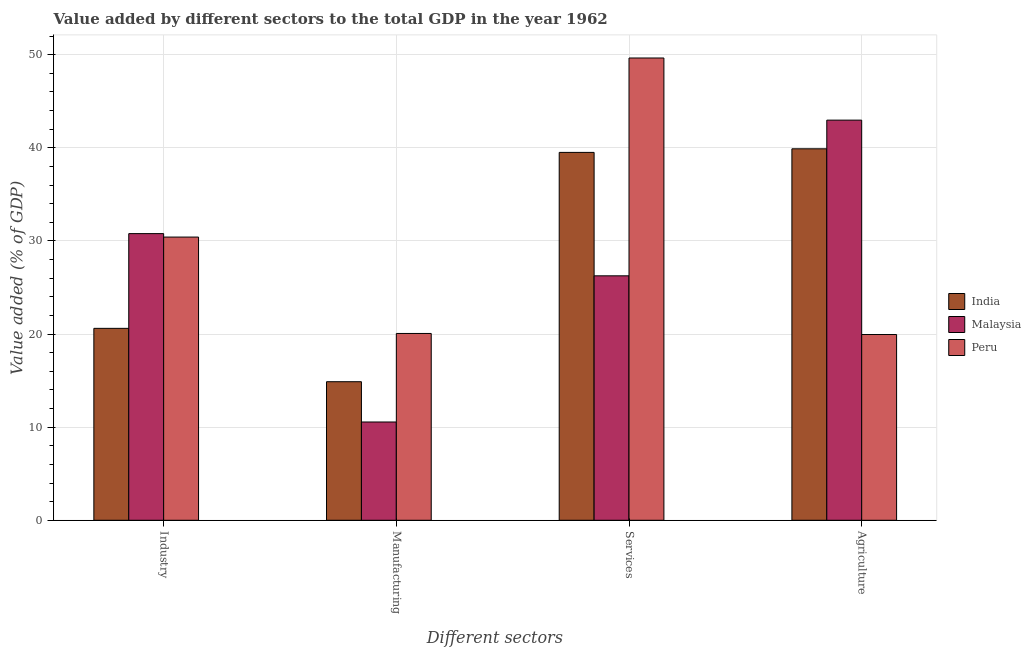How many groups of bars are there?
Your answer should be compact. 4. Are the number of bars per tick equal to the number of legend labels?
Ensure brevity in your answer.  Yes. Are the number of bars on each tick of the X-axis equal?
Provide a short and direct response. Yes. How many bars are there on the 3rd tick from the right?
Your answer should be compact. 3. What is the label of the 4th group of bars from the left?
Offer a terse response. Agriculture. What is the value added by manufacturing sector in Malaysia?
Offer a terse response. 10.55. Across all countries, what is the maximum value added by agricultural sector?
Your response must be concise. 42.97. Across all countries, what is the minimum value added by industrial sector?
Keep it short and to the point. 20.61. In which country was the value added by industrial sector maximum?
Give a very brief answer. Malaysia. What is the total value added by services sector in the graph?
Give a very brief answer. 115.39. What is the difference between the value added by industrial sector in Peru and that in India?
Provide a short and direct response. 9.8. What is the difference between the value added by agricultural sector in Malaysia and the value added by manufacturing sector in India?
Provide a succinct answer. 28.09. What is the average value added by manufacturing sector per country?
Provide a succinct answer. 15.16. What is the difference between the value added by agricultural sector and value added by industrial sector in India?
Offer a very short reply. 19.28. In how many countries, is the value added by manufacturing sector greater than 16 %?
Provide a succinct answer. 1. What is the ratio of the value added by industrial sector in Peru to that in India?
Your response must be concise. 1.48. Is the value added by services sector in Peru less than that in Malaysia?
Your answer should be very brief. No. Is the difference between the value added by services sector in India and Malaysia greater than the difference between the value added by manufacturing sector in India and Malaysia?
Provide a succinct answer. Yes. What is the difference between the highest and the second highest value added by agricultural sector?
Give a very brief answer. 3.08. What is the difference between the highest and the lowest value added by manufacturing sector?
Provide a succinct answer. 9.51. In how many countries, is the value added by services sector greater than the average value added by services sector taken over all countries?
Your answer should be very brief. 2. What does the 2nd bar from the left in Agriculture represents?
Keep it short and to the point. Malaysia. What does the 1st bar from the right in Services represents?
Your response must be concise. Peru. Is it the case that in every country, the sum of the value added by industrial sector and value added by manufacturing sector is greater than the value added by services sector?
Keep it short and to the point. No. How many bars are there?
Provide a short and direct response. 12. Are all the bars in the graph horizontal?
Your answer should be compact. No. What is the difference between two consecutive major ticks on the Y-axis?
Your response must be concise. 10. Does the graph contain any zero values?
Make the answer very short. No. Does the graph contain grids?
Your answer should be compact. Yes. Where does the legend appear in the graph?
Your answer should be very brief. Center right. How are the legend labels stacked?
Your answer should be compact. Vertical. What is the title of the graph?
Your answer should be very brief. Value added by different sectors to the total GDP in the year 1962. What is the label or title of the X-axis?
Make the answer very short. Different sectors. What is the label or title of the Y-axis?
Ensure brevity in your answer.  Value added (% of GDP). What is the Value added (% of GDP) of India in Industry?
Offer a very short reply. 20.61. What is the Value added (% of GDP) of Malaysia in Industry?
Make the answer very short. 30.78. What is the Value added (% of GDP) of Peru in Industry?
Offer a terse response. 30.41. What is the Value added (% of GDP) of India in Manufacturing?
Ensure brevity in your answer.  14.88. What is the Value added (% of GDP) in Malaysia in Manufacturing?
Provide a short and direct response. 10.55. What is the Value added (% of GDP) of Peru in Manufacturing?
Make the answer very short. 20.06. What is the Value added (% of GDP) in India in Services?
Provide a short and direct response. 39.5. What is the Value added (% of GDP) of Malaysia in Services?
Give a very brief answer. 26.25. What is the Value added (% of GDP) of Peru in Services?
Keep it short and to the point. 49.64. What is the Value added (% of GDP) in India in Agriculture?
Provide a short and direct response. 39.89. What is the Value added (% of GDP) in Malaysia in Agriculture?
Offer a terse response. 42.97. What is the Value added (% of GDP) in Peru in Agriculture?
Keep it short and to the point. 19.95. Across all Different sectors, what is the maximum Value added (% of GDP) of India?
Your response must be concise. 39.89. Across all Different sectors, what is the maximum Value added (% of GDP) in Malaysia?
Your answer should be compact. 42.97. Across all Different sectors, what is the maximum Value added (% of GDP) in Peru?
Make the answer very short. 49.64. Across all Different sectors, what is the minimum Value added (% of GDP) of India?
Offer a very short reply. 14.88. Across all Different sectors, what is the minimum Value added (% of GDP) in Malaysia?
Offer a terse response. 10.55. Across all Different sectors, what is the minimum Value added (% of GDP) in Peru?
Offer a terse response. 19.95. What is the total Value added (% of GDP) in India in the graph?
Provide a succinct answer. 114.88. What is the total Value added (% of GDP) of Malaysia in the graph?
Provide a succinct answer. 110.55. What is the total Value added (% of GDP) of Peru in the graph?
Offer a very short reply. 120.06. What is the difference between the Value added (% of GDP) of India in Industry and that in Manufacturing?
Provide a short and direct response. 5.73. What is the difference between the Value added (% of GDP) of Malaysia in Industry and that in Manufacturing?
Provide a succinct answer. 20.23. What is the difference between the Value added (% of GDP) in Peru in Industry and that in Manufacturing?
Ensure brevity in your answer.  10.35. What is the difference between the Value added (% of GDP) in India in Industry and that in Services?
Provide a succinct answer. -18.89. What is the difference between the Value added (% of GDP) in Malaysia in Industry and that in Services?
Offer a terse response. 4.53. What is the difference between the Value added (% of GDP) of Peru in Industry and that in Services?
Your response must be concise. -19.23. What is the difference between the Value added (% of GDP) of India in Industry and that in Agriculture?
Your response must be concise. -19.28. What is the difference between the Value added (% of GDP) in Malaysia in Industry and that in Agriculture?
Offer a terse response. -12.19. What is the difference between the Value added (% of GDP) of Peru in Industry and that in Agriculture?
Give a very brief answer. 10.46. What is the difference between the Value added (% of GDP) in India in Manufacturing and that in Services?
Your answer should be very brief. -24.62. What is the difference between the Value added (% of GDP) of Malaysia in Manufacturing and that in Services?
Ensure brevity in your answer.  -15.7. What is the difference between the Value added (% of GDP) in Peru in Manufacturing and that in Services?
Your answer should be compact. -29.58. What is the difference between the Value added (% of GDP) in India in Manufacturing and that in Agriculture?
Offer a terse response. -25.01. What is the difference between the Value added (% of GDP) of Malaysia in Manufacturing and that in Agriculture?
Your response must be concise. -32.42. What is the difference between the Value added (% of GDP) in Peru in Manufacturing and that in Agriculture?
Make the answer very short. 0.11. What is the difference between the Value added (% of GDP) in India in Services and that in Agriculture?
Keep it short and to the point. -0.39. What is the difference between the Value added (% of GDP) in Malaysia in Services and that in Agriculture?
Your response must be concise. -16.72. What is the difference between the Value added (% of GDP) in Peru in Services and that in Agriculture?
Offer a very short reply. 29.69. What is the difference between the Value added (% of GDP) in India in Industry and the Value added (% of GDP) in Malaysia in Manufacturing?
Offer a very short reply. 10.06. What is the difference between the Value added (% of GDP) of India in Industry and the Value added (% of GDP) of Peru in Manufacturing?
Offer a very short reply. 0.55. What is the difference between the Value added (% of GDP) of Malaysia in Industry and the Value added (% of GDP) of Peru in Manufacturing?
Your answer should be compact. 10.72. What is the difference between the Value added (% of GDP) in India in Industry and the Value added (% of GDP) in Malaysia in Services?
Make the answer very short. -5.64. What is the difference between the Value added (% of GDP) of India in Industry and the Value added (% of GDP) of Peru in Services?
Your answer should be compact. -29.03. What is the difference between the Value added (% of GDP) of Malaysia in Industry and the Value added (% of GDP) of Peru in Services?
Provide a short and direct response. -18.86. What is the difference between the Value added (% of GDP) of India in Industry and the Value added (% of GDP) of Malaysia in Agriculture?
Offer a very short reply. -22.36. What is the difference between the Value added (% of GDP) in India in Industry and the Value added (% of GDP) in Peru in Agriculture?
Your response must be concise. 0.66. What is the difference between the Value added (% of GDP) of Malaysia in Industry and the Value added (% of GDP) of Peru in Agriculture?
Give a very brief answer. 10.84. What is the difference between the Value added (% of GDP) of India in Manufacturing and the Value added (% of GDP) of Malaysia in Services?
Keep it short and to the point. -11.37. What is the difference between the Value added (% of GDP) of India in Manufacturing and the Value added (% of GDP) of Peru in Services?
Your answer should be compact. -34.76. What is the difference between the Value added (% of GDP) of Malaysia in Manufacturing and the Value added (% of GDP) of Peru in Services?
Ensure brevity in your answer.  -39.09. What is the difference between the Value added (% of GDP) of India in Manufacturing and the Value added (% of GDP) of Malaysia in Agriculture?
Offer a very short reply. -28.09. What is the difference between the Value added (% of GDP) in India in Manufacturing and the Value added (% of GDP) in Peru in Agriculture?
Ensure brevity in your answer.  -5.07. What is the difference between the Value added (% of GDP) in Malaysia in Manufacturing and the Value added (% of GDP) in Peru in Agriculture?
Offer a terse response. -9.39. What is the difference between the Value added (% of GDP) in India in Services and the Value added (% of GDP) in Malaysia in Agriculture?
Your answer should be compact. -3.47. What is the difference between the Value added (% of GDP) of India in Services and the Value added (% of GDP) of Peru in Agriculture?
Offer a terse response. 19.56. What is the difference between the Value added (% of GDP) in Malaysia in Services and the Value added (% of GDP) in Peru in Agriculture?
Keep it short and to the point. 6.3. What is the average Value added (% of GDP) in India per Different sectors?
Make the answer very short. 28.72. What is the average Value added (% of GDP) in Malaysia per Different sectors?
Keep it short and to the point. 27.64. What is the average Value added (% of GDP) of Peru per Different sectors?
Your response must be concise. 30.02. What is the difference between the Value added (% of GDP) in India and Value added (% of GDP) in Malaysia in Industry?
Provide a short and direct response. -10.17. What is the difference between the Value added (% of GDP) of India and Value added (% of GDP) of Peru in Industry?
Ensure brevity in your answer.  -9.8. What is the difference between the Value added (% of GDP) in Malaysia and Value added (% of GDP) in Peru in Industry?
Your answer should be compact. 0.37. What is the difference between the Value added (% of GDP) of India and Value added (% of GDP) of Malaysia in Manufacturing?
Provide a short and direct response. 4.33. What is the difference between the Value added (% of GDP) of India and Value added (% of GDP) of Peru in Manufacturing?
Your answer should be compact. -5.18. What is the difference between the Value added (% of GDP) in Malaysia and Value added (% of GDP) in Peru in Manufacturing?
Make the answer very short. -9.51. What is the difference between the Value added (% of GDP) of India and Value added (% of GDP) of Malaysia in Services?
Offer a terse response. 13.25. What is the difference between the Value added (% of GDP) of India and Value added (% of GDP) of Peru in Services?
Make the answer very short. -10.14. What is the difference between the Value added (% of GDP) of Malaysia and Value added (% of GDP) of Peru in Services?
Provide a short and direct response. -23.39. What is the difference between the Value added (% of GDP) of India and Value added (% of GDP) of Malaysia in Agriculture?
Make the answer very short. -3.08. What is the difference between the Value added (% of GDP) in India and Value added (% of GDP) in Peru in Agriculture?
Your answer should be compact. 19.94. What is the difference between the Value added (% of GDP) in Malaysia and Value added (% of GDP) in Peru in Agriculture?
Provide a succinct answer. 23.02. What is the ratio of the Value added (% of GDP) in India in Industry to that in Manufacturing?
Your answer should be compact. 1.39. What is the ratio of the Value added (% of GDP) in Malaysia in Industry to that in Manufacturing?
Keep it short and to the point. 2.92. What is the ratio of the Value added (% of GDP) in Peru in Industry to that in Manufacturing?
Ensure brevity in your answer.  1.52. What is the ratio of the Value added (% of GDP) in India in Industry to that in Services?
Offer a very short reply. 0.52. What is the ratio of the Value added (% of GDP) of Malaysia in Industry to that in Services?
Your answer should be very brief. 1.17. What is the ratio of the Value added (% of GDP) in Peru in Industry to that in Services?
Offer a terse response. 0.61. What is the ratio of the Value added (% of GDP) of India in Industry to that in Agriculture?
Keep it short and to the point. 0.52. What is the ratio of the Value added (% of GDP) of Malaysia in Industry to that in Agriculture?
Make the answer very short. 0.72. What is the ratio of the Value added (% of GDP) in Peru in Industry to that in Agriculture?
Offer a terse response. 1.52. What is the ratio of the Value added (% of GDP) of India in Manufacturing to that in Services?
Offer a terse response. 0.38. What is the ratio of the Value added (% of GDP) of Malaysia in Manufacturing to that in Services?
Ensure brevity in your answer.  0.4. What is the ratio of the Value added (% of GDP) in Peru in Manufacturing to that in Services?
Ensure brevity in your answer.  0.4. What is the ratio of the Value added (% of GDP) of India in Manufacturing to that in Agriculture?
Keep it short and to the point. 0.37. What is the ratio of the Value added (% of GDP) in Malaysia in Manufacturing to that in Agriculture?
Give a very brief answer. 0.25. What is the ratio of the Value added (% of GDP) in India in Services to that in Agriculture?
Offer a very short reply. 0.99. What is the ratio of the Value added (% of GDP) in Malaysia in Services to that in Agriculture?
Offer a terse response. 0.61. What is the ratio of the Value added (% of GDP) in Peru in Services to that in Agriculture?
Make the answer very short. 2.49. What is the difference between the highest and the second highest Value added (% of GDP) in India?
Provide a succinct answer. 0.39. What is the difference between the highest and the second highest Value added (% of GDP) of Malaysia?
Your response must be concise. 12.19. What is the difference between the highest and the second highest Value added (% of GDP) in Peru?
Your response must be concise. 19.23. What is the difference between the highest and the lowest Value added (% of GDP) of India?
Your answer should be very brief. 25.01. What is the difference between the highest and the lowest Value added (% of GDP) of Malaysia?
Your answer should be very brief. 32.42. What is the difference between the highest and the lowest Value added (% of GDP) of Peru?
Ensure brevity in your answer.  29.69. 